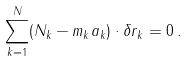Convert formula to latex. <formula><loc_0><loc_0><loc_500><loc_500>\sum _ { k = 1 } ^ { N } ( N _ { k } - m _ { k } a _ { k } ) \cdot \delta r _ { k } = 0 \, .</formula> 